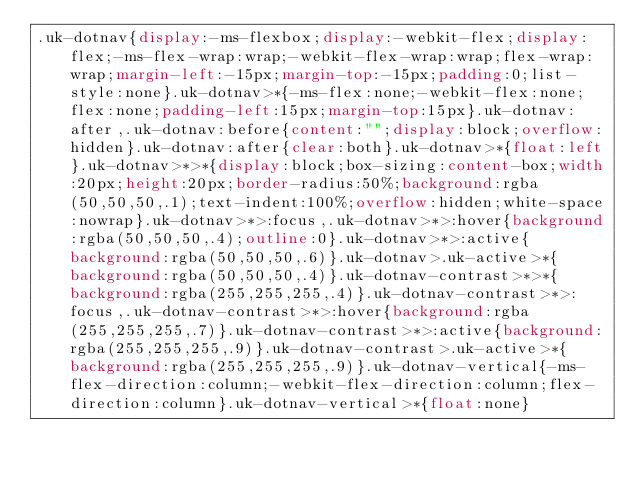Convert code to text. <code><loc_0><loc_0><loc_500><loc_500><_CSS_>.uk-dotnav{display:-ms-flexbox;display:-webkit-flex;display:flex;-ms-flex-wrap:wrap;-webkit-flex-wrap:wrap;flex-wrap:wrap;margin-left:-15px;margin-top:-15px;padding:0;list-style:none}.uk-dotnav>*{-ms-flex:none;-webkit-flex:none;flex:none;padding-left:15px;margin-top:15px}.uk-dotnav:after,.uk-dotnav:before{content:"";display:block;overflow:hidden}.uk-dotnav:after{clear:both}.uk-dotnav>*{float:left}.uk-dotnav>*>*{display:block;box-sizing:content-box;width:20px;height:20px;border-radius:50%;background:rgba(50,50,50,.1);text-indent:100%;overflow:hidden;white-space:nowrap}.uk-dotnav>*>:focus,.uk-dotnav>*>:hover{background:rgba(50,50,50,.4);outline:0}.uk-dotnav>*>:active{background:rgba(50,50,50,.6)}.uk-dotnav>.uk-active>*{background:rgba(50,50,50,.4)}.uk-dotnav-contrast>*>*{background:rgba(255,255,255,.4)}.uk-dotnav-contrast>*>:focus,.uk-dotnav-contrast>*>:hover{background:rgba(255,255,255,.7)}.uk-dotnav-contrast>*>:active{background:rgba(255,255,255,.9)}.uk-dotnav-contrast>.uk-active>*{background:rgba(255,255,255,.9)}.uk-dotnav-vertical{-ms-flex-direction:column;-webkit-flex-direction:column;flex-direction:column}.uk-dotnav-vertical>*{float:none}</code> 